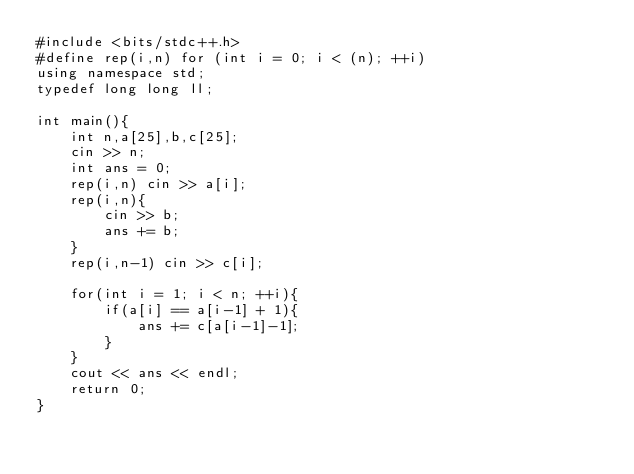Convert code to text. <code><loc_0><loc_0><loc_500><loc_500><_C++_>#include <bits/stdc++.h>
#define rep(i,n) for (int i = 0; i < (n); ++i)
using namespace std;
typedef long long ll;

int main(){
    int n,a[25],b,c[25];
    cin >> n;
    int ans = 0;
    rep(i,n) cin >> a[i];
    rep(i,n){
        cin >> b;
        ans += b;
    }
    rep(i,n-1) cin >> c[i];

    for(int i = 1; i < n; ++i){
        if(a[i] == a[i-1] + 1){
            ans += c[a[i-1]-1];
        }
    }
    cout << ans << endl;
    return 0;
}</code> 